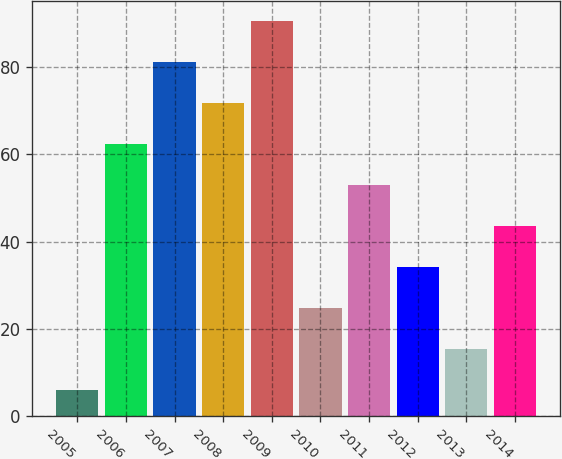Convert chart. <chart><loc_0><loc_0><loc_500><loc_500><bar_chart><fcel>2005<fcel>2006<fcel>2007<fcel>2008<fcel>2009<fcel>2010<fcel>2011<fcel>2012<fcel>2013<fcel>2014<nl><fcel>6<fcel>62.4<fcel>81.2<fcel>71.8<fcel>90.6<fcel>24.8<fcel>53<fcel>34.2<fcel>15.4<fcel>43.6<nl></chart> 